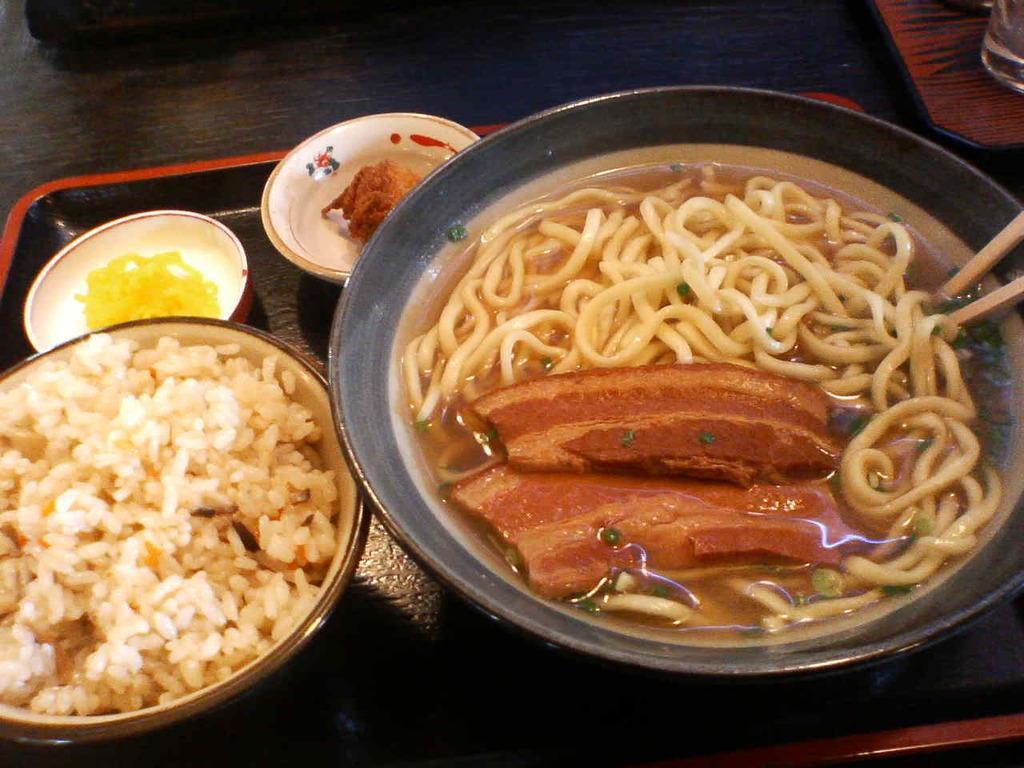Could you give a brief overview of what you see in this image? In this image there are noodles, meat , soup with 2 chopsticks inside a bowl , 3 bowls with food in a bowl in a tray on a table and a glass. 